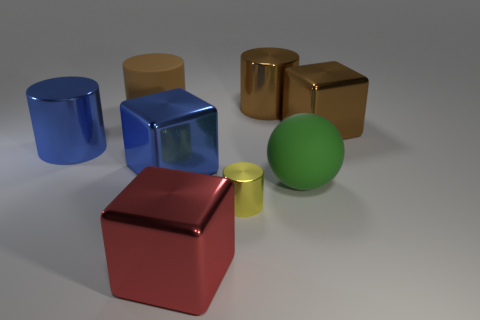Is there any other thing that has the same size as the yellow cylinder?
Keep it short and to the point. No. There is a blue metal object left of the block to the left of the red thing; what is its shape?
Provide a succinct answer. Cylinder. Do the metal cube that is in front of the blue metal block and the rubber ball have the same size?
Your answer should be compact. Yes. How big is the object that is both to the left of the small yellow object and behind the large blue cylinder?
Provide a short and direct response. Large. What number of red things have the same size as the blue cylinder?
Your answer should be compact. 1. There is a rubber thing that is in front of the big brown cube; what number of large brown objects are to the left of it?
Your response must be concise. 2. Is the color of the big block to the right of the big green thing the same as the rubber cylinder?
Your answer should be very brief. Yes. There is a shiny cube that is behind the big metallic cylinder that is left of the tiny yellow shiny object; are there any big cylinders that are behind it?
Offer a very short reply. Yes. There is a object that is both in front of the large blue cylinder and on the left side of the large red object; what shape is it?
Provide a succinct answer. Cube. Is there another cylinder of the same color as the big rubber cylinder?
Provide a short and direct response. Yes. 